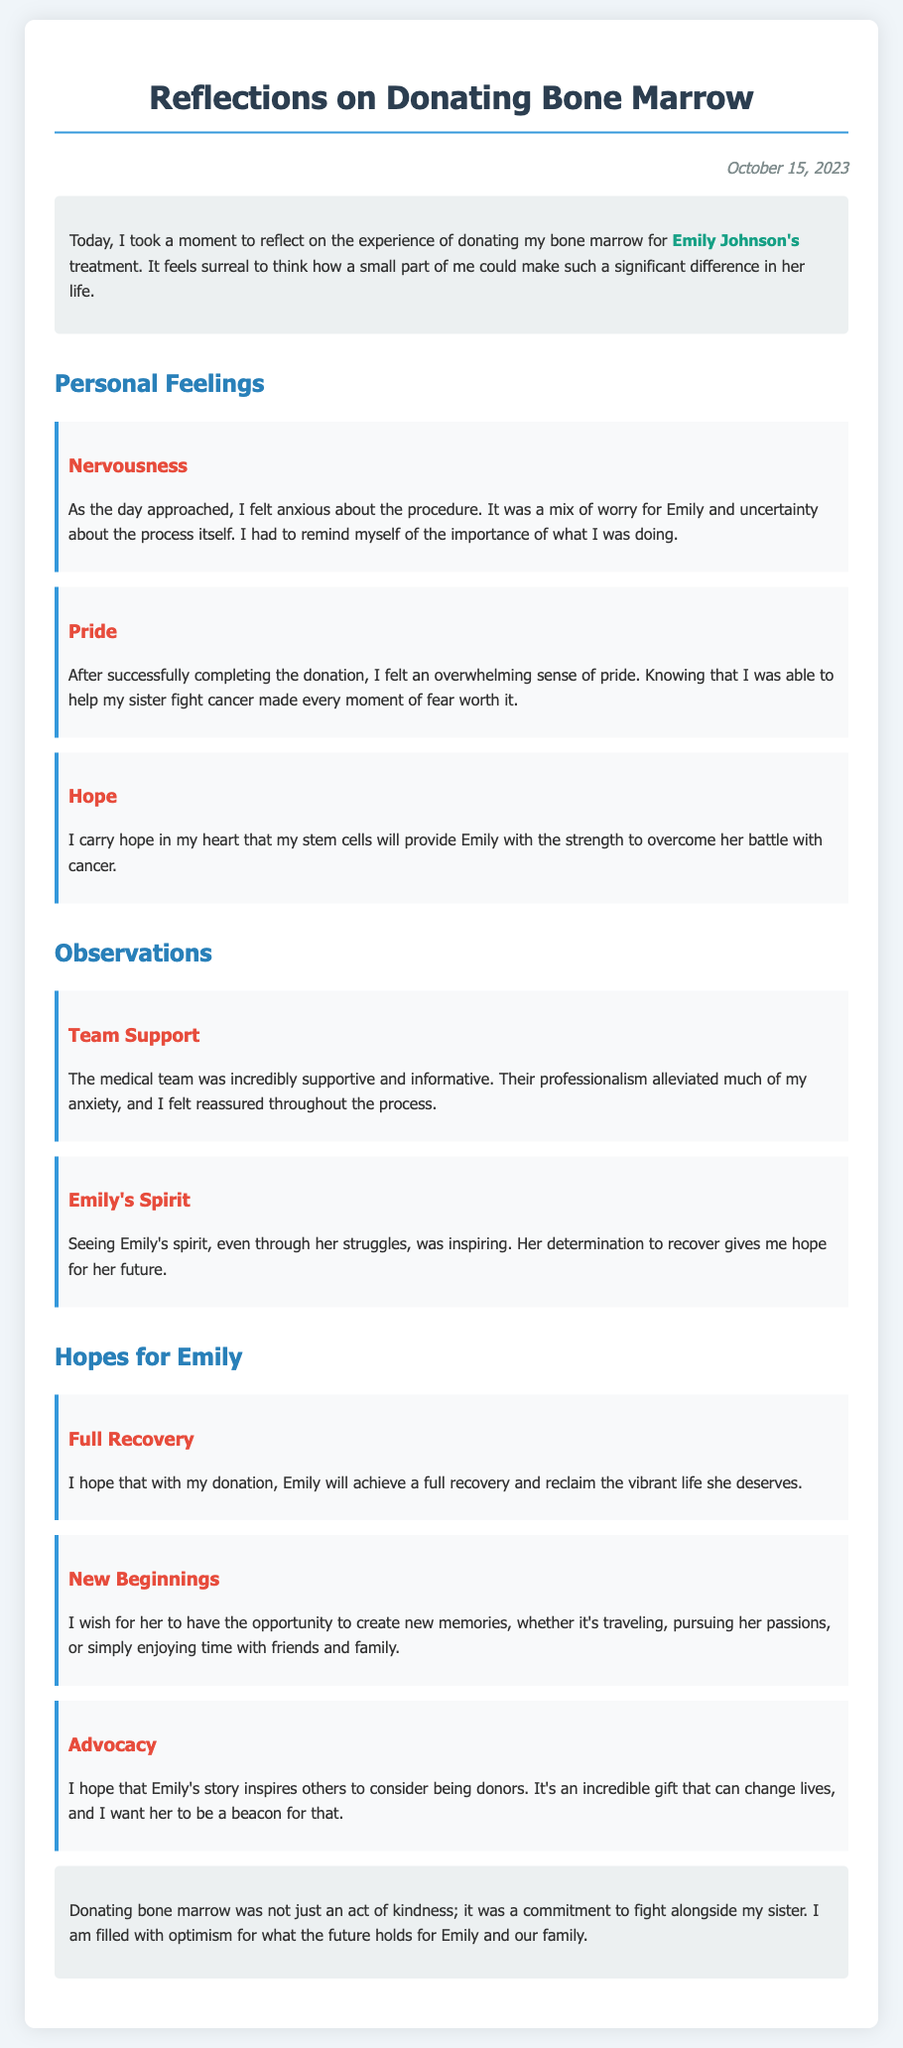What is the recipient's name? The recipient's name is explicitly mentioned in the introduction of the document as Emily Johnson.
Answer: Emily Johnson What date was the journal entry written? The date of the journal entry is stated at the top of the document.
Answer: October 15, 2023 What emotion did the author feel before the donation? The author shares their emotions about the procedure, specifically nervousness before the donation process.
Answer: Nervousness What was the author's feeling after the donation? The author felt a strong emotion related to pride after the successful completion of the donation.
Answer: Pride What does the author hope for Emily's future? The author expresses a hope that Emily will achieve a full recovery and reclaim her vibrant life.
Answer: Full recovery What observation did the author make about the medical team? The author remarks on the support provided by the medical team, highlighting their professionalism.
Answer: Team Support What role does Emily's spirit play in the author's reflections? The author finds inspiration in Emily's spirit, noting it as a source of hope for her future.
Answer: Emily's Spirit What is one of the hopes the author has for Emily regarding her future experiences? The author wishes for Emily to create new memories, including traveling and pursuing passions.
Answer: New memories What type of commitment does the author describe donating bone marrow as? The author describes donating bone marrow not just as an act of kindness but as a commitment to fight alongside Emily.
Answer: Commitment 